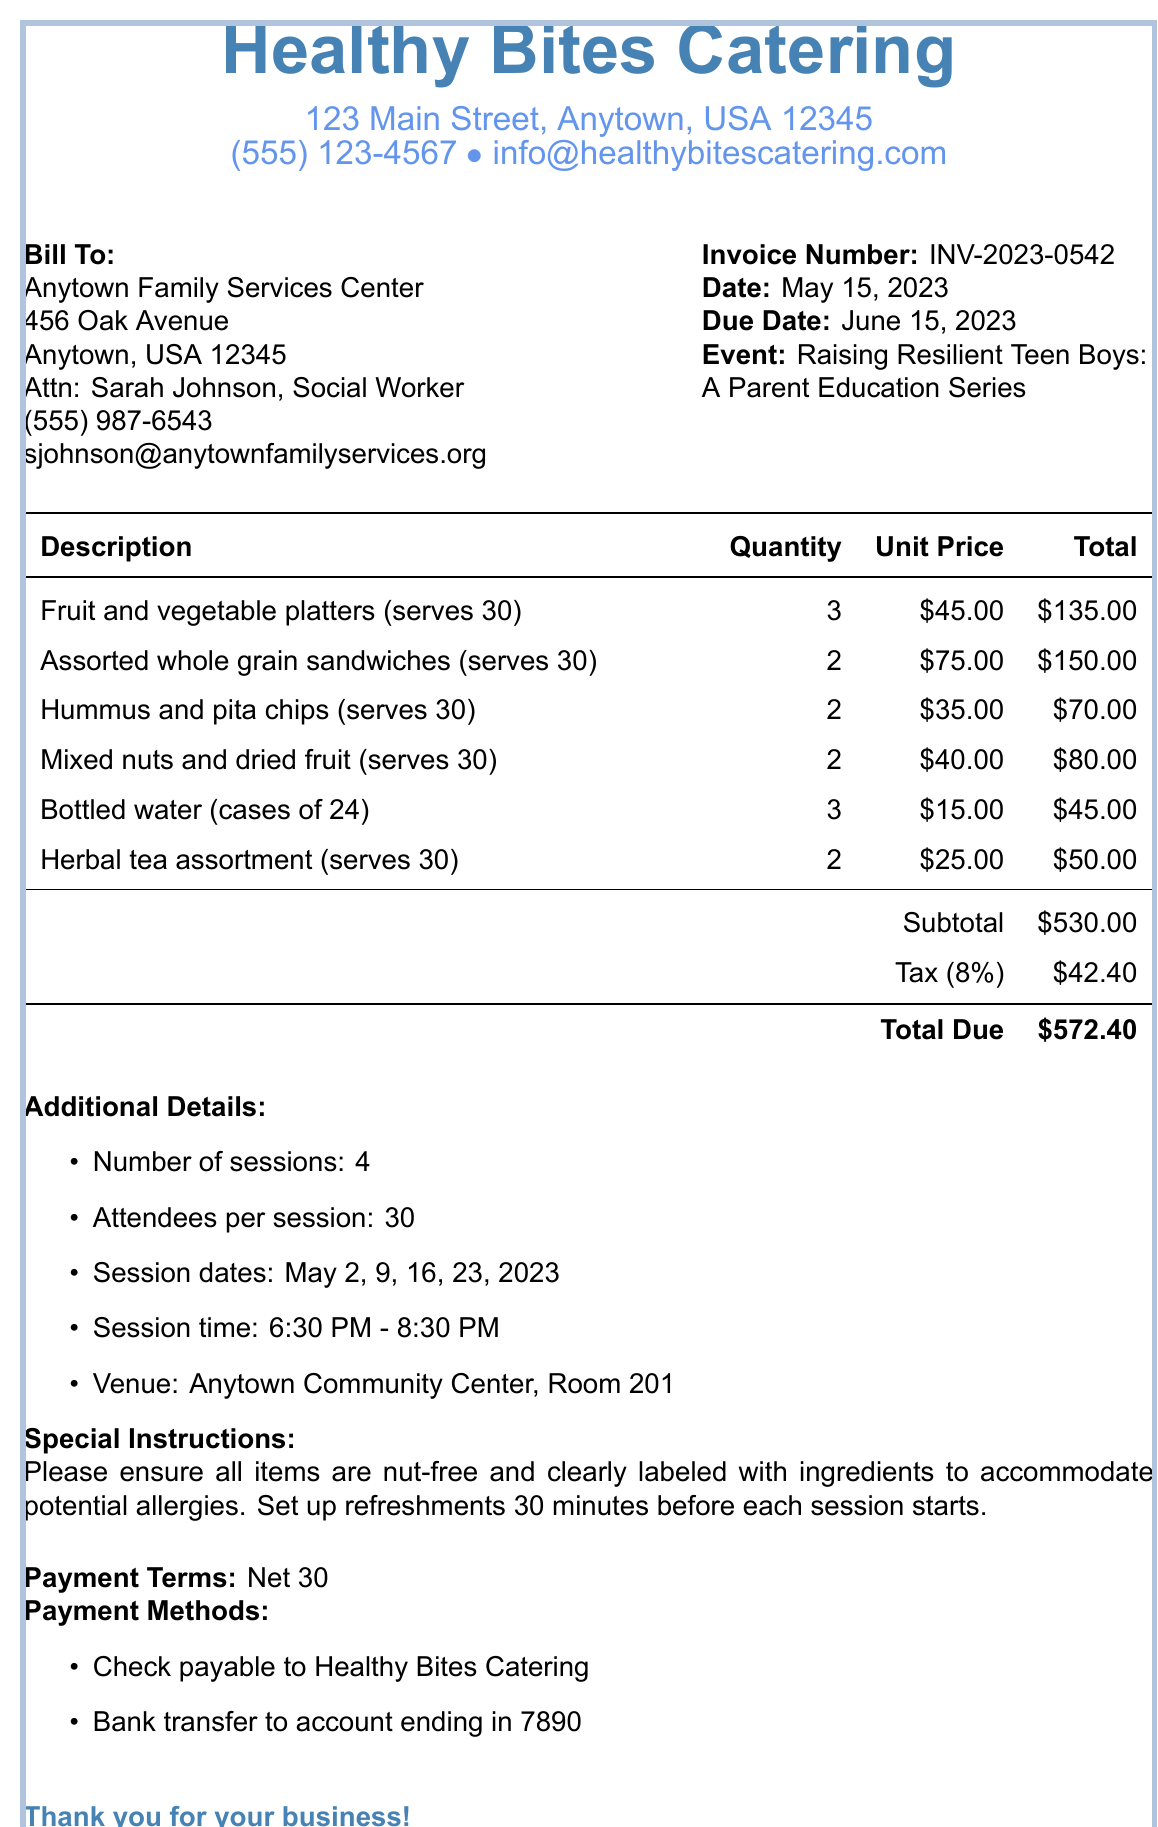What is the invoice number? The invoice number can be found in the document details section, specified as INV-2023-0542.
Answer: INV-2023-0542 What is the due date of the invoice? The due date is provided in the document and is listed as June 15, 2023.
Answer: June 15, 2023 Who is the contact person for the client? The contact person is mentioned in the client details section as Sarah Johnson, Social Worker.
Answer: Sarah Johnson, Social Worker How many attendees are expected per session? The document specifies that there will be 30 attendees per session under additional details.
Answer: 30 What is the subtotal of the invoice? The subtotal appears in the financial details section, listed as $530.00.
Answer: $530.00 How many sessions are included in the event? The number of sessions is clearly stated in the additional details as 4 sessions.
Answer: 4 What is the total amount due? The total amount due is found at the end of the financial section, noted as $572.40.
Answer: $572.40 What special instructions are provided for the catering? The document includes instructions for nut-free items and labeling ingredients clearly.
Answer: Nut-free and clearly labeled with ingredients What is the tax rate applied to the invoice? The tax rate can be found in the financial section of the document as 8%.
Answer: 8% 